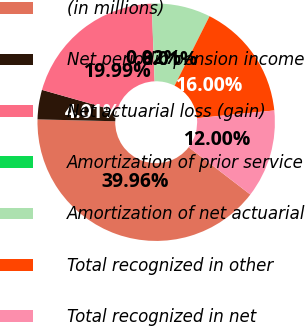Convert chart. <chart><loc_0><loc_0><loc_500><loc_500><pie_chart><fcel>(in millions)<fcel>Net periodic pension income<fcel>Net actuarial loss (gain)<fcel>Amortization of prior service<fcel>Amortization of net actuarial<fcel>Total recognized in other<fcel>Total recognized in net<nl><fcel>39.96%<fcel>4.01%<fcel>19.99%<fcel>0.02%<fcel>8.01%<fcel>16.0%<fcel>12.0%<nl></chart> 